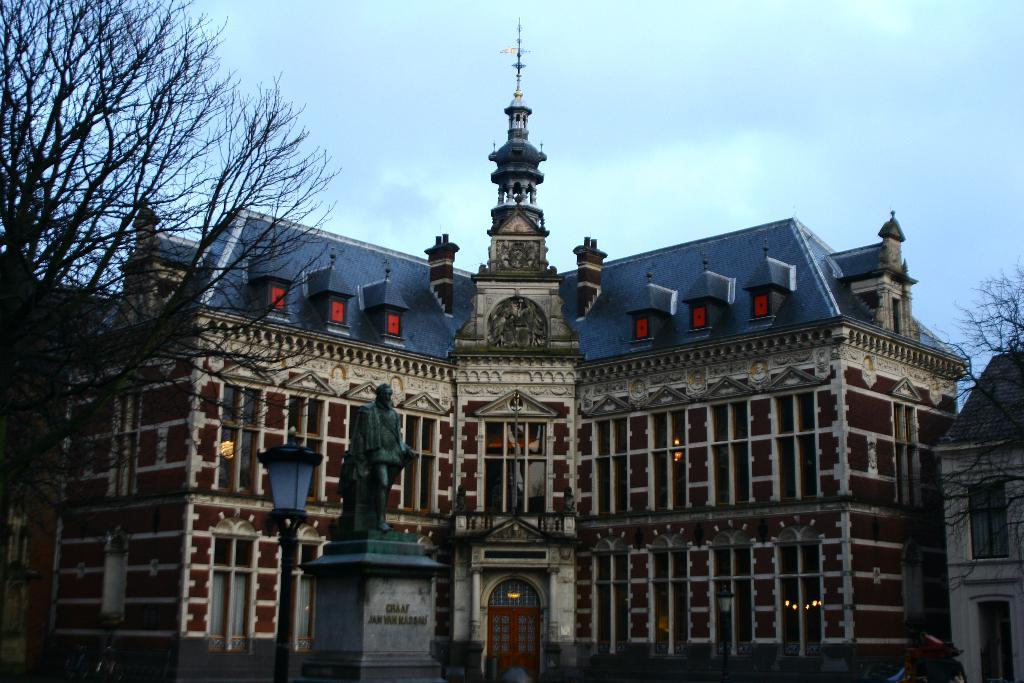What type of structure is present in the image? There is a building in the image. What can be seen illuminating the area in the image? There are lights in the image. What object is present that might be used for supporting signs or other items? There is a pole in the image. What artistic feature is present in the image? There is a statue in the image. What mode of transportation can be seen in the image? There is a bike in the image. What is visible at the top of the image? The sky is visible at the top of the image. What is the mass of the time that is present in the image? There is no time present in the image, and therefore no mass can be determined. What process is being depicted in the image? The image does not depict a specific process; it shows a building, lights, a pole, a statue, a bike, and the sky. 